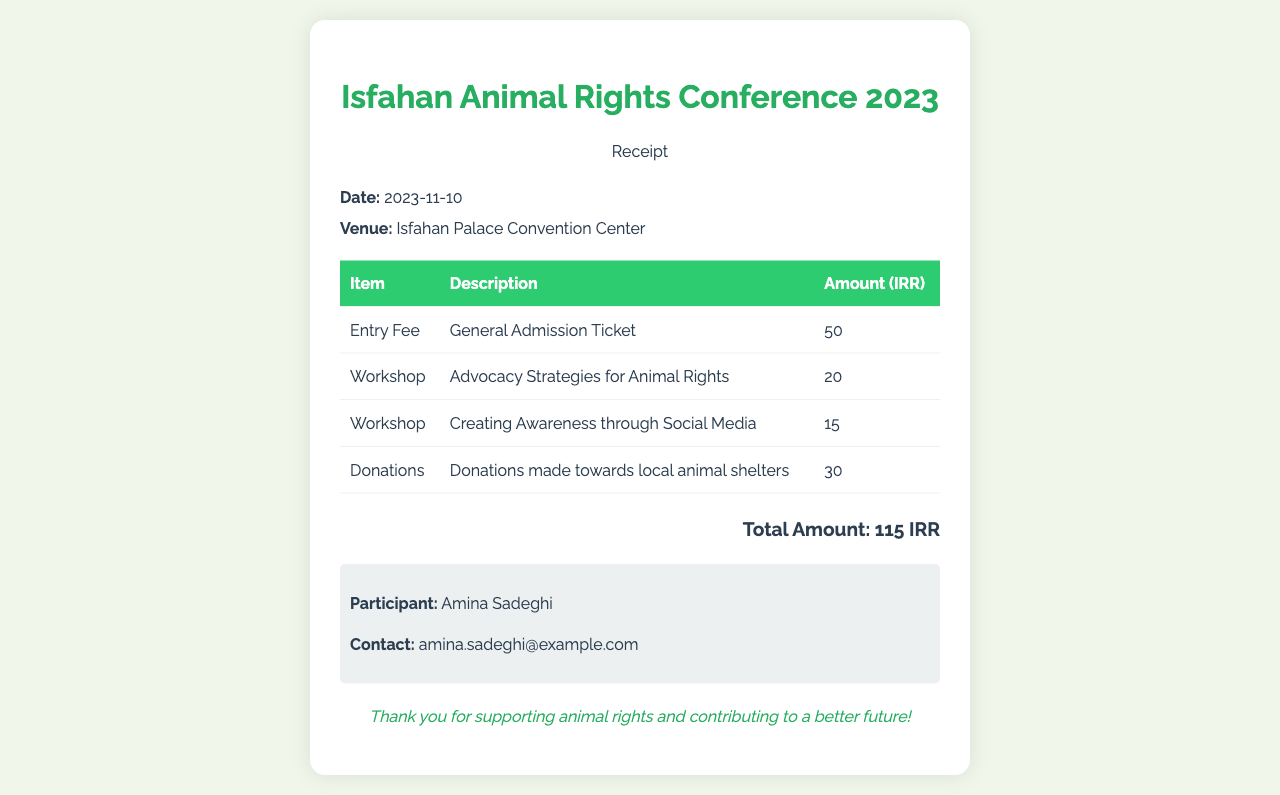What is the date of the conference? The date of the conference is listed in the document's information section.
Answer: 2023-11-10 What is the venue for the conference? The venue is specified in the information section of the document.
Answer: Isfahan Palace Convention Center What is the entry fee amount? The entry fee is detailed in the table under "Amount" next to "Entry Fee".
Answer: 50 How many workshops are listed in the document? The number of workshops can be determined by counting the relevant rows in the table.
Answer: 2 What is the total amount stated at the bottom of the receipt? The total amount is calculated from the sum of the individual items in the receipt.
Answer: 115 IRR What is the participant's name? The participant's name is mentioned in the section designated for participant details.
Answer: Amina Sadeghi What donation amount is mentioned? The donation amount can be found in the table under the "Donations" entry.
Answer: 30 What type of workshop is offered related to social media? The type of workshop is described in the table under the "Description" column for the second workshop.
Answer: Creating Awareness through Social Media What is the tone of the thank-you message? The thank-you message conveys appreciation and encouragement, as reflected in its content.
Answer: Supportive 